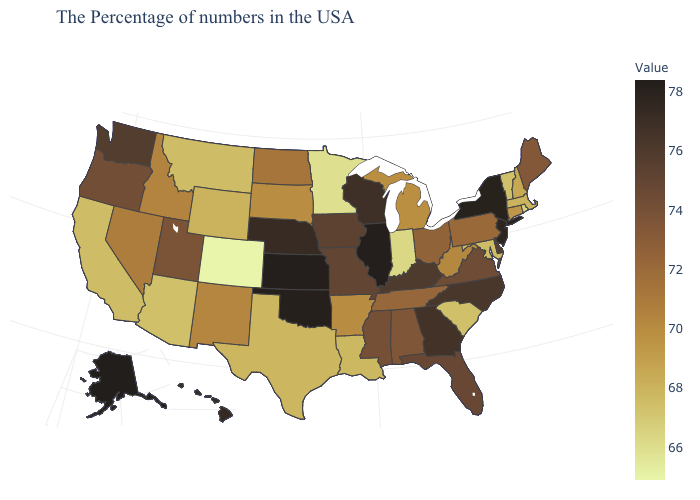Which states hav the highest value in the MidWest?
Give a very brief answer. Illinois, Kansas. Is the legend a continuous bar?
Concise answer only. Yes. Does Kansas have the highest value in the MidWest?
Short answer required. Yes. Does Alaska have the highest value in the USA?
Write a very short answer. Yes. Among the states that border California , does Oregon have the highest value?
Be succinct. Yes. Among the states that border New Hampshire , which have the lowest value?
Quick response, please. Vermont. 